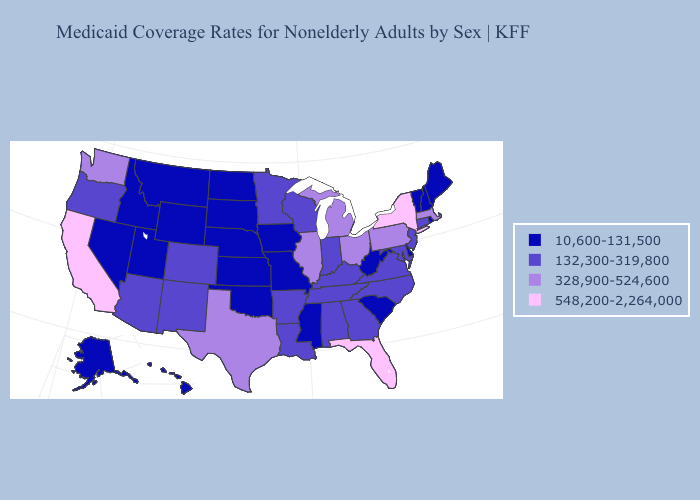Name the states that have a value in the range 132,300-319,800?
Concise answer only. Alabama, Arizona, Arkansas, Colorado, Connecticut, Georgia, Indiana, Kentucky, Louisiana, Maryland, Minnesota, New Jersey, New Mexico, North Carolina, Oregon, Tennessee, Virginia, Wisconsin. Does New Jersey have the highest value in the Northeast?
Be succinct. No. What is the value of Connecticut?
Concise answer only. 132,300-319,800. What is the lowest value in states that border Wisconsin?
Answer briefly. 10,600-131,500. Which states have the highest value in the USA?
Be succinct. California, Florida, New York. What is the value of Ohio?
Be succinct. 328,900-524,600. What is the value of Wyoming?
Give a very brief answer. 10,600-131,500. Does South Carolina have a higher value than New York?
Keep it brief. No. Among the states that border New Mexico , does Texas have the highest value?
Short answer required. Yes. Name the states that have a value in the range 328,900-524,600?
Answer briefly. Illinois, Massachusetts, Michigan, Ohio, Pennsylvania, Texas, Washington. Name the states that have a value in the range 328,900-524,600?
Be succinct. Illinois, Massachusetts, Michigan, Ohio, Pennsylvania, Texas, Washington. What is the lowest value in states that border Nevada?
Answer briefly. 10,600-131,500. Name the states that have a value in the range 328,900-524,600?
Write a very short answer. Illinois, Massachusetts, Michigan, Ohio, Pennsylvania, Texas, Washington. What is the value of South Carolina?
Keep it brief. 10,600-131,500. 